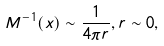<formula> <loc_0><loc_0><loc_500><loc_500>M ^ { - 1 } ( x ) \sim \frac { 1 } { 4 \pi r } , r \sim 0 ,</formula> 